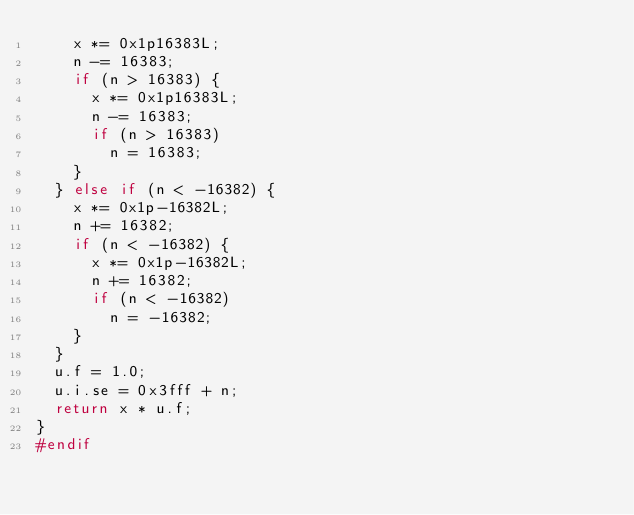<code> <loc_0><loc_0><loc_500><loc_500><_C_>		x *= 0x1p16383L;
		n -= 16383;
		if (n > 16383) {
			x *= 0x1p16383L;
			n -= 16383;
			if (n > 16383)
				n = 16383;
		}
	} else if (n < -16382) {
		x *= 0x1p-16382L;
		n += 16382;
		if (n < -16382) {
			x *= 0x1p-16382L;
			n += 16382;
			if (n < -16382)
				n = -16382;
		}
	}
	u.f = 1.0;
	u.i.se = 0x3fff + n;
	return x * u.f;
}
#endif
</code> 